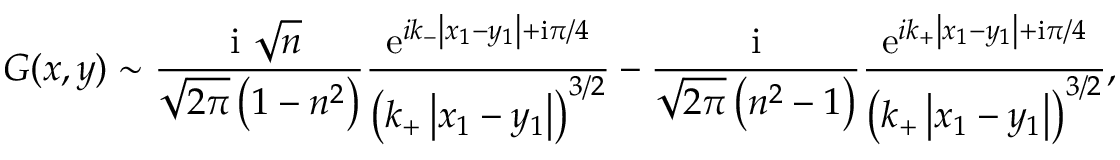Convert formula to latex. <formula><loc_0><loc_0><loc_500><loc_500>G ( x , y ) \sim \frac { i \sqrt { n } } { \sqrt { 2 \pi } \left ( 1 - n ^ { 2 } \right ) } \frac { e ^ { i k _ { - } \left | x _ { 1 } - y _ { 1 } \right | + i \pi / 4 } } { \left ( k _ { + } \left | x _ { 1 } - y _ { 1 } \right | \right ) ^ { 3 / 2 } } - \frac { i } { \sqrt { 2 \pi } \left ( n ^ { 2 } - 1 \right ) } \frac { e ^ { i k _ { + } \left | x _ { 1 } - y _ { 1 } \right | + i \pi / 4 } } { \left ( k _ { + } \left | x _ { 1 } - y _ { 1 } \right | \right ) ^ { 3 / 2 } } ,</formula> 